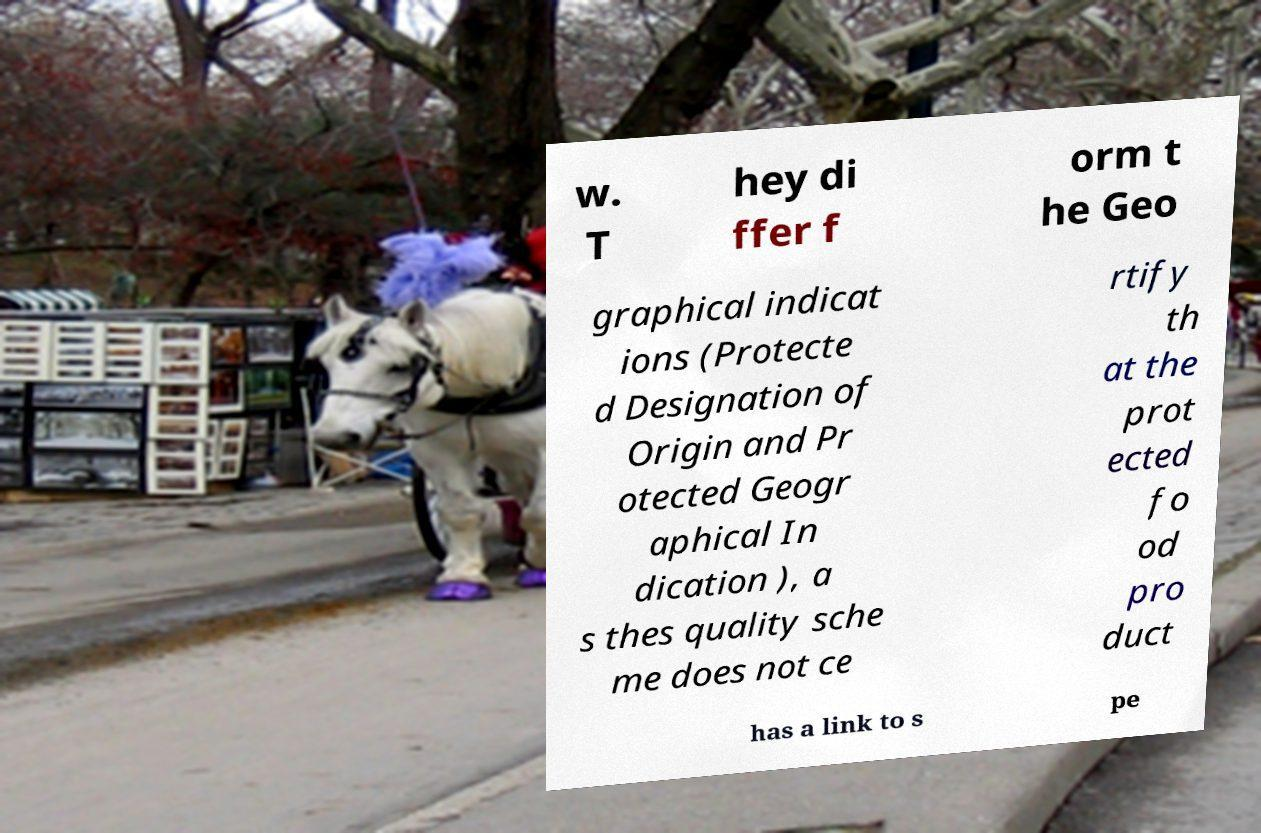Could you extract and type out the text from this image? w. T hey di ffer f orm t he Geo graphical indicat ions (Protecte d Designation of Origin and Pr otected Geogr aphical In dication ), a s thes quality sche me does not ce rtify th at the prot ected fo od pro duct has a link to s pe 